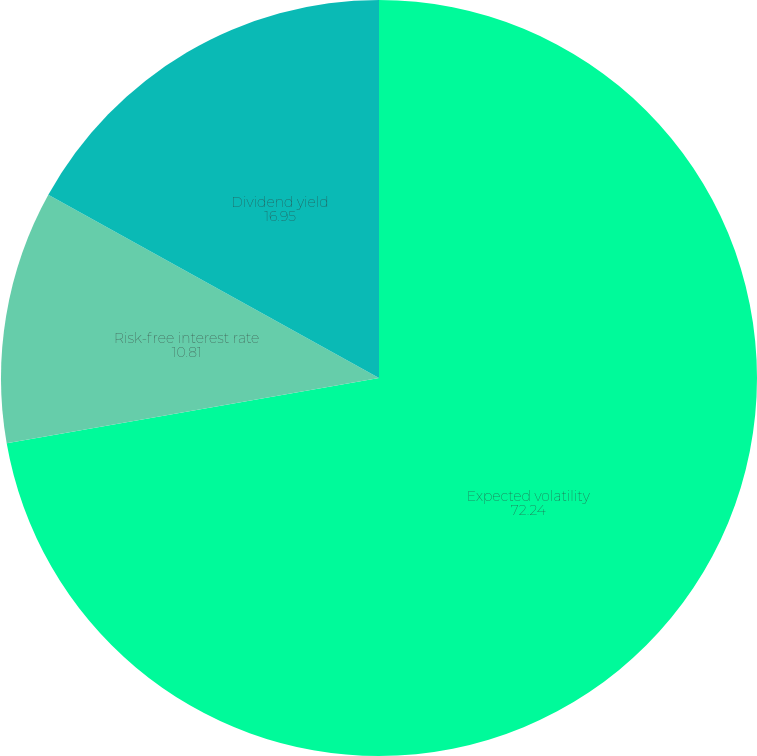Convert chart to OTSL. <chart><loc_0><loc_0><loc_500><loc_500><pie_chart><fcel>Expected volatility<fcel>Risk-free interest rate<fcel>Dividend yield<nl><fcel>72.24%<fcel>10.81%<fcel>16.95%<nl></chart> 